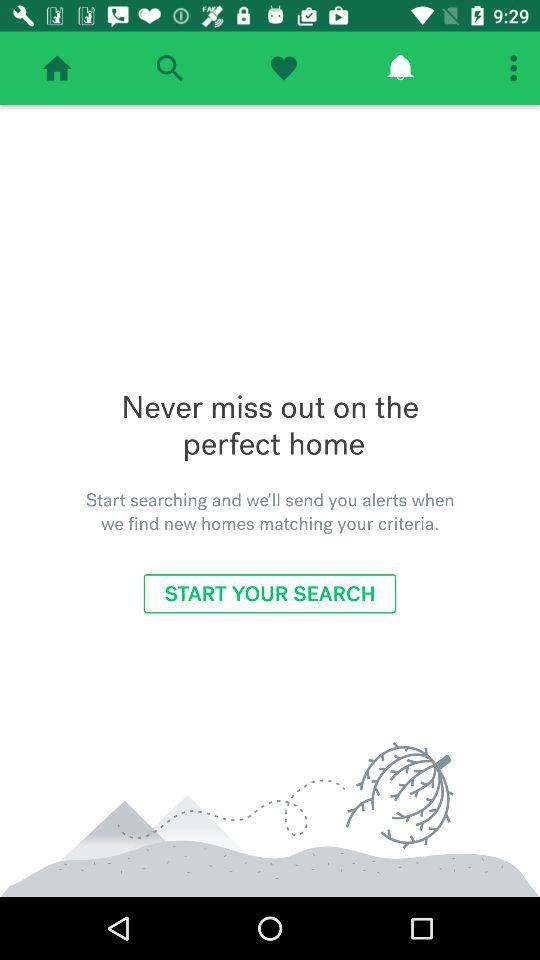What tab has been selected? The selected tab is "Notification". 